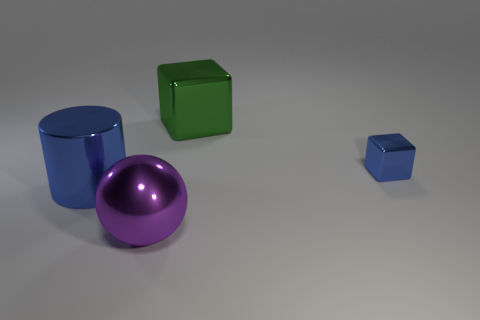Add 3 large purple metal balls. How many objects exist? 7 Subtract all balls. How many objects are left? 3 Add 3 small blue blocks. How many small blue blocks are left? 4 Add 1 green shiny blocks. How many green shiny blocks exist? 2 Subtract 0 blue balls. How many objects are left? 4 Subtract all purple rubber spheres. Subtract all large spheres. How many objects are left? 3 